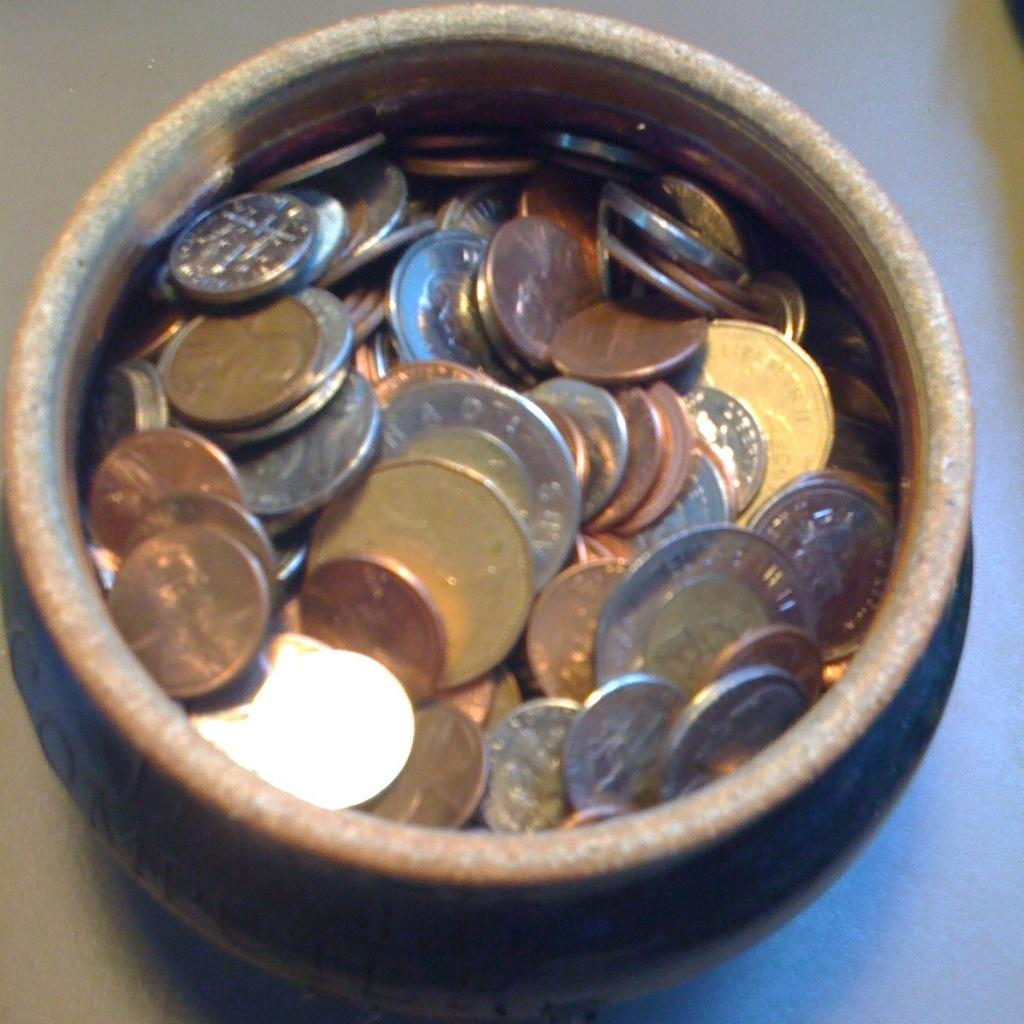What objects are present in the image? There are many coins in the image. Where are the coins located? The coins are in a bowl. Can you describe the location of the bowl? The bowl is on a table. How many bikes are visible in the image? There are no bikes present in the image. What type of mitten is being used to measure the coins in the image? There is no mitten present in the image, and the coins are not being measured. 